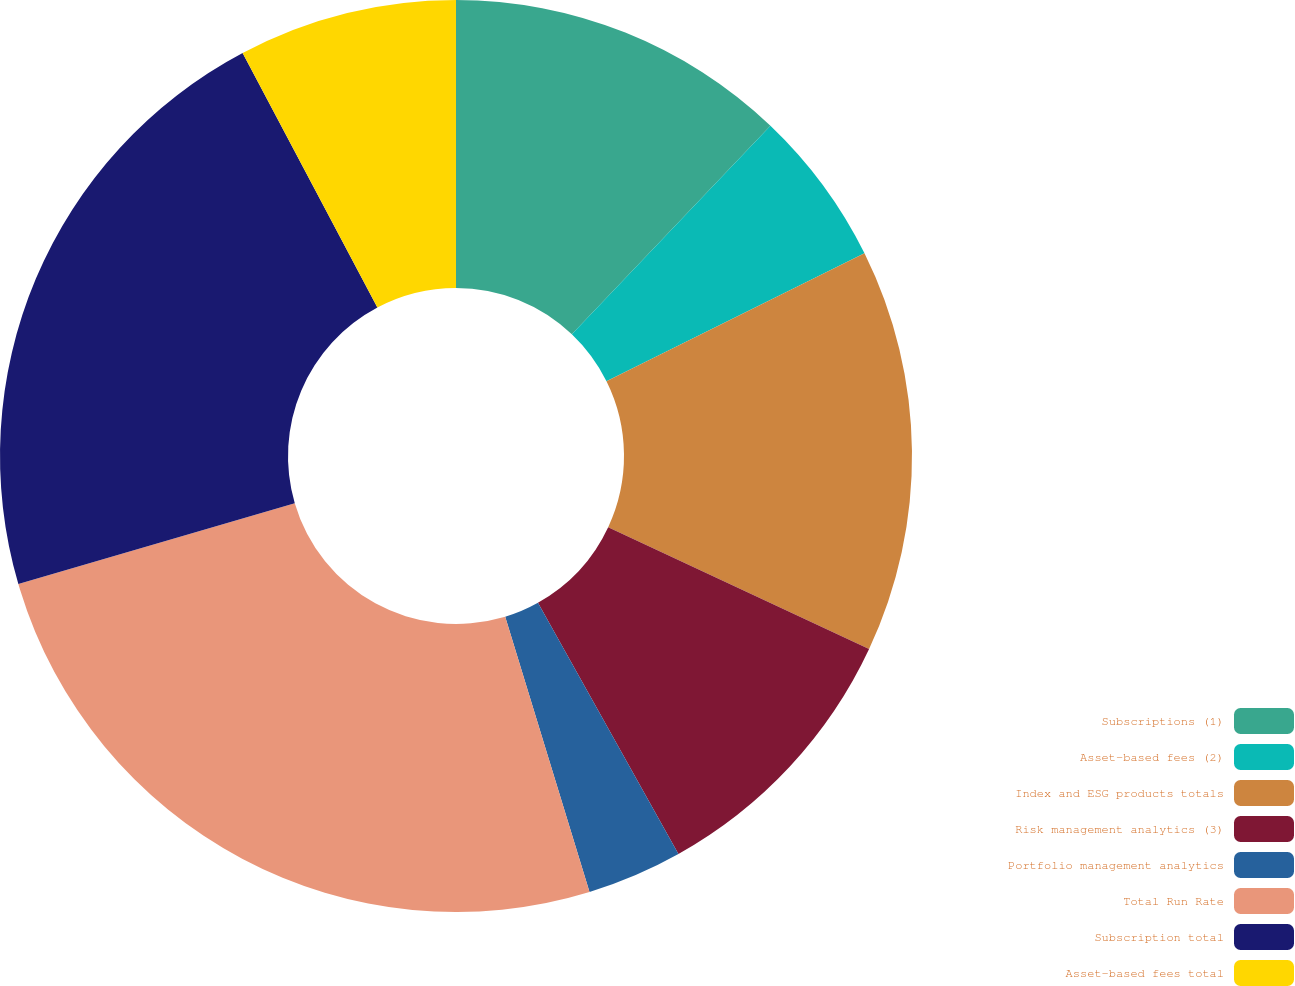Convert chart to OTSL. <chart><loc_0><loc_0><loc_500><loc_500><pie_chart><fcel>Subscriptions (1)<fcel>Asset-based fees (2)<fcel>Index and ESG products totals<fcel>Risk management analytics (3)<fcel>Portfolio management analytics<fcel>Total Run Rate<fcel>Subscription total<fcel>Asset-based fees total<nl><fcel>12.11%<fcel>5.56%<fcel>14.29%<fcel>9.93%<fcel>3.38%<fcel>25.2%<fcel>21.78%<fcel>7.75%<nl></chart> 